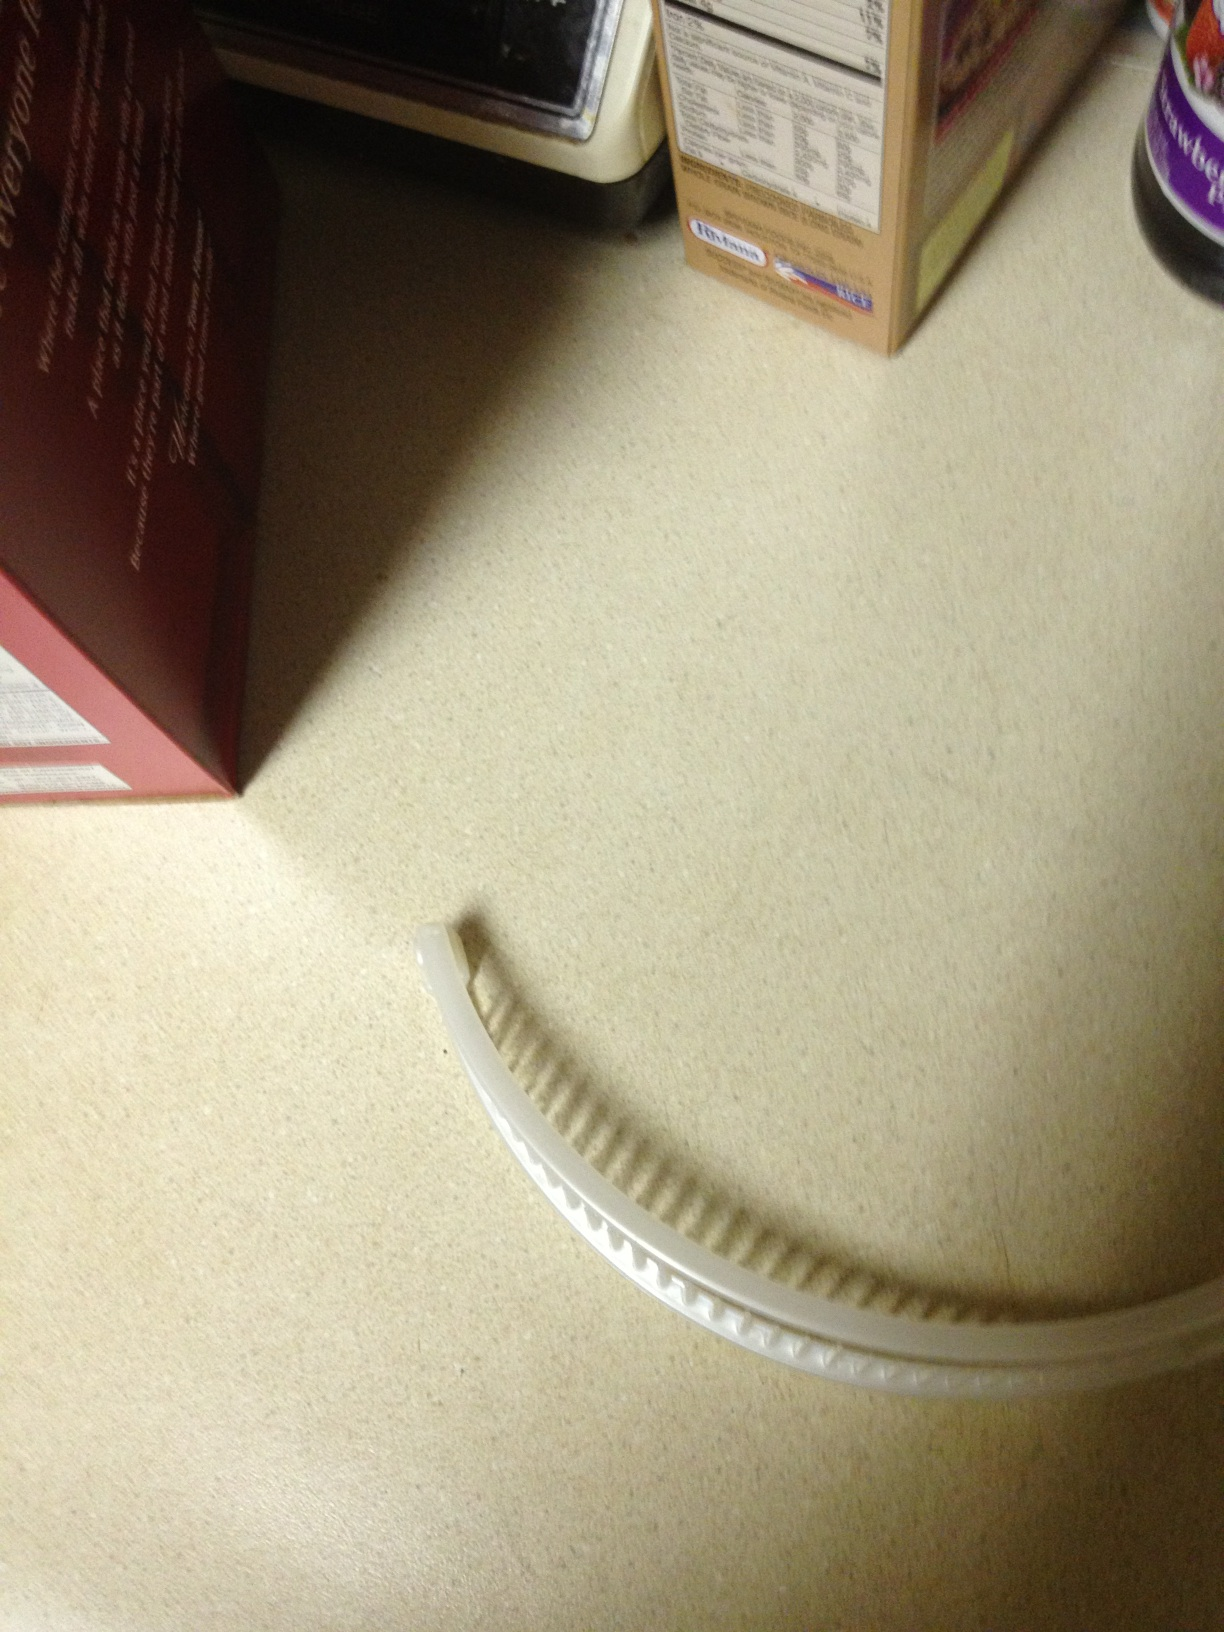What color is this banana hair clip? The banana hair clip in the image is white. It has a clean and even color, typical for this style of hair accessory, which can help in securely holding the hair together while adding a simple yet elegant touch. 